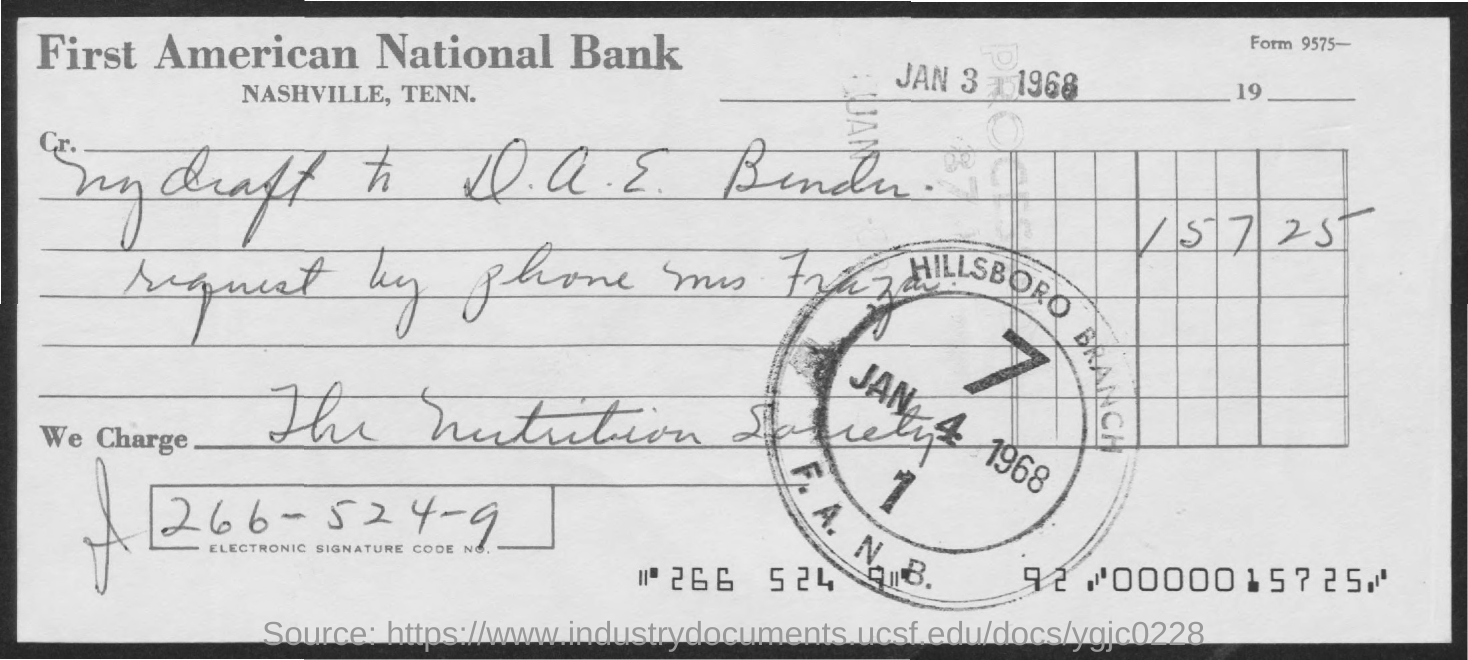Indicate a few pertinent items in this graphic. The document's date is January 3, 1968. The electronic signature code number is 266-524-9... 